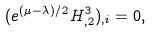Convert formula to latex. <formula><loc_0><loc_0><loc_500><loc_500>( e ^ { ( \mu - \lambda ) / 2 } H ^ { 3 } _ { , 2 } ) _ { , i } = 0 ,</formula> 